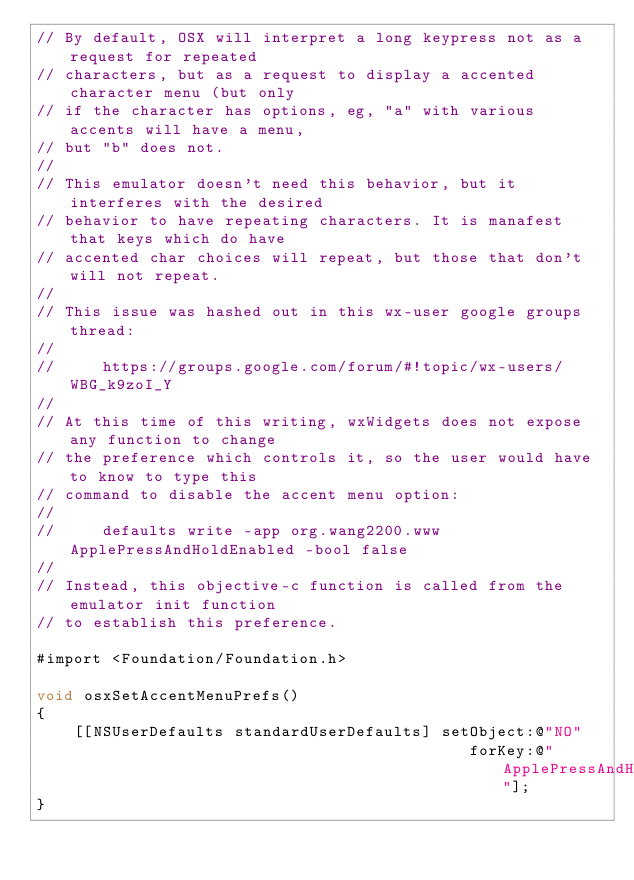Convert code to text. <code><loc_0><loc_0><loc_500><loc_500><_ObjectiveC_>// By default, OSX will interpret a long keypress not as a request for repeated
// characters, but as a request to display a accented character menu (but only
// if the character has options, eg, "a" with various accents will have a menu,
// but "b" does not.
//
// This emulator doesn't need this behavior, but it interferes with the desired
// behavior to have repeating characters. It is manafest that keys which do have
// accented char choices will repeat, but those that don't will not repeat.
//
// This issue was hashed out in this wx-user google groups thread:
//
//     https://groups.google.com/forum/#!topic/wx-users/WBG_k9zoI_Y
//
// At this time of this writing, wxWidgets does not expose any function to change
// the preference which controls it, so the user would have to know to type this
// command to disable the accent menu option:
//
//     defaults write -app org.wang2200.www ApplePressAndHoldEnabled -bool false
//
// Instead, this objective-c function is called from the emulator init function
// to establish this preference.

#import <Foundation/Foundation.h>

void osxSetAccentMenuPrefs()
{
    [[NSUserDefaults standardUserDefaults] setObject:@"NO"
                                              forKey:@"ApplePressAndHoldEnabled"];
}
</code> 